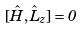Convert formula to latex. <formula><loc_0><loc_0><loc_500><loc_500>[ \hat { H } , \hat { L } _ { z } ] = 0</formula> 